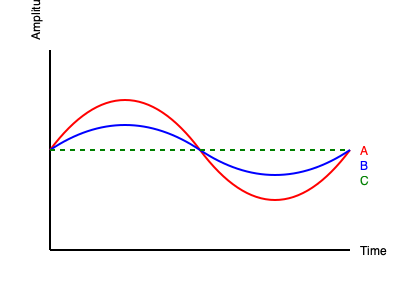In the waveform comparison of different distortion pedal settings used in Mucc's songs, which line represents the setting with the highest gain and most aggressive clipping? To answer this question, let's analyze the waveforms represented in the graph:

1. The green dashed line (C) represents a clean, unmodified sine wave. This is the original guitar signal without any distortion.

2. The blue line (B) shows a mild distortion. The peaks of the sine wave are slightly flattened, indicating some soft clipping. This represents a low to medium gain setting on a distortion pedal.

3. The red line (A) displays the most extreme modification of the original sine wave. The peaks are significantly flattened and squared off, which is characteristic of hard clipping.

In distortion pedal terminology:
- Higher gain settings result in more aggressive clipping of the waveform.
- More aggressive clipping leads to a more distorted, saturated sound.
- Hard clipping, as seen in the red waveform, produces a more intense, compressed, and harmonically rich distortion often used in heavy metal and hard rock.

Mucc, known for their heavy sound in many songs, would likely use high-gain distortion settings to achieve their signature tone.

Therefore, the red line (A) represents the setting with the highest gain and most aggressive clipping, as it shows the most extreme modification of the original sine wave.
Answer: Red line (A) 